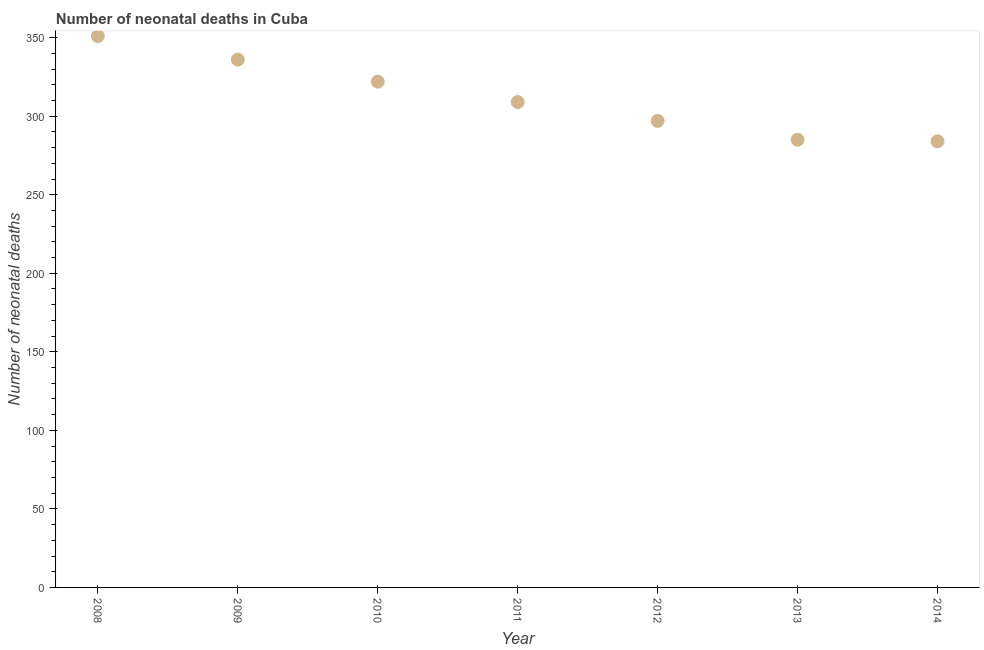What is the number of neonatal deaths in 2009?
Your response must be concise. 336. Across all years, what is the maximum number of neonatal deaths?
Give a very brief answer. 351. Across all years, what is the minimum number of neonatal deaths?
Your answer should be compact. 284. In which year was the number of neonatal deaths maximum?
Give a very brief answer. 2008. In which year was the number of neonatal deaths minimum?
Your response must be concise. 2014. What is the sum of the number of neonatal deaths?
Provide a short and direct response. 2184. What is the difference between the number of neonatal deaths in 2012 and 2013?
Ensure brevity in your answer.  12. What is the average number of neonatal deaths per year?
Keep it short and to the point. 312. What is the median number of neonatal deaths?
Your answer should be very brief. 309. What is the ratio of the number of neonatal deaths in 2010 to that in 2014?
Offer a very short reply. 1.13. Is the number of neonatal deaths in 2010 less than that in 2013?
Provide a short and direct response. No. Is the sum of the number of neonatal deaths in 2011 and 2014 greater than the maximum number of neonatal deaths across all years?
Ensure brevity in your answer.  Yes. What is the difference between the highest and the lowest number of neonatal deaths?
Offer a terse response. 67. In how many years, is the number of neonatal deaths greater than the average number of neonatal deaths taken over all years?
Provide a short and direct response. 3. How many dotlines are there?
Your response must be concise. 1. How many years are there in the graph?
Give a very brief answer. 7. What is the difference between two consecutive major ticks on the Y-axis?
Keep it short and to the point. 50. Are the values on the major ticks of Y-axis written in scientific E-notation?
Provide a short and direct response. No. Does the graph contain grids?
Give a very brief answer. No. What is the title of the graph?
Provide a short and direct response. Number of neonatal deaths in Cuba. What is the label or title of the Y-axis?
Your answer should be very brief. Number of neonatal deaths. What is the Number of neonatal deaths in 2008?
Provide a short and direct response. 351. What is the Number of neonatal deaths in 2009?
Give a very brief answer. 336. What is the Number of neonatal deaths in 2010?
Offer a terse response. 322. What is the Number of neonatal deaths in 2011?
Ensure brevity in your answer.  309. What is the Number of neonatal deaths in 2012?
Give a very brief answer. 297. What is the Number of neonatal deaths in 2013?
Make the answer very short. 285. What is the Number of neonatal deaths in 2014?
Offer a terse response. 284. What is the difference between the Number of neonatal deaths in 2008 and 2013?
Offer a very short reply. 66. What is the difference between the Number of neonatal deaths in 2008 and 2014?
Provide a short and direct response. 67. What is the difference between the Number of neonatal deaths in 2009 and 2011?
Offer a terse response. 27. What is the difference between the Number of neonatal deaths in 2009 and 2013?
Make the answer very short. 51. What is the difference between the Number of neonatal deaths in 2010 and 2012?
Offer a terse response. 25. What is the difference between the Number of neonatal deaths in 2010 and 2013?
Offer a very short reply. 37. What is the difference between the Number of neonatal deaths in 2010 and 2014?
Provide a succinct answer. 38. What is the difference between the Number of neonatal deaths in 2012 and 2014?
Ensure brevity in your answer.  13. What is the difference between the Number of neonatal deaths in 2013 and 2014?
Provide a short and direct response. 1. What is the ratio of the Number of neonatal deaths in 2008 to that in 2009?
Offer a terse response. 1.04. What is the ratio of the Number of neonatal deaths in 2008 to that in 2010?
Your response must be concise. 1.09. What is the ratio of the Number of neonatal deaths in 2008 to that in 2011?
Provide a succinct answer. 1.14. What is the ratio of the Number of neonatal deaths in 2008 to that in 2012?
Provide a succinct answer. 1.18. What is the ratio of the Number of neonatal deaths in 2008 to that in 2013?
Provide a short and direct response. 1.23. What is the ratio of the Number of neonatal deaths in 2008 to that in 2014?
Keep it short and to the point. 1.24. What is the ratio of the Number of neonatal deaths in 2009 to that in 2010?
Provide a succinct answer. 1.04. What is the ratio of the Number of neonatal deaths in 2009 to that in 2011?
Your answer should be very brief. 1.09. What is the ratio of the Number of neonatal deaths in 2009 to that in 2012?
Provide a succinct answer. 1.13. What is the ratio of the Number of neonatal deaths in 2009 to that in 2013?
Keep it short and to the point. 1.18. What is the ratio of the Number of neonatal deaths in 2009 to that in 2014?
Give a very brief answer. 1.18. What is the ratio of the Number of neonatal deaths in 2010 to that in 2011?
Your answer should be very brief. 1.04. What is the ratio of the Number of neonatal deaths in 2010 to that in 2012?
Your response must be concise. 1.08. What is the ratio of the Number of neonatal deaths in 2010 to that in 2013?
Your answer should be very brief. 1.13. What is the ratio of the Number of neonatal deaths in 2010 to that in 2014?
Give a very brief answer. 1.13. What is the ratio of the Number of neonatal deaths in 2011 to that in 2012?
Provide a succinct answer. 1.04. What is the ratio of the Number of neonatal deaths in 2011 to that in 2013?
Provide a succinct answer. 1.08. What is the ratio of the Number of neonatal deaths in 2011 to that in 2014?
Provide a short and direct response. 1.09. What is the ratio of the Number of neonatal deaths in 2012 to that in 2013?
Your answer should be very brief. 1.04. What is the ratio of the Number of neonatal deaths in 2012 to that in 2014?
Your answer should be very brief. 1.05. What is the ratio of the Number of neonatal deaths in 2013 to that in 2014?
Keep it short and to the point. 1. 